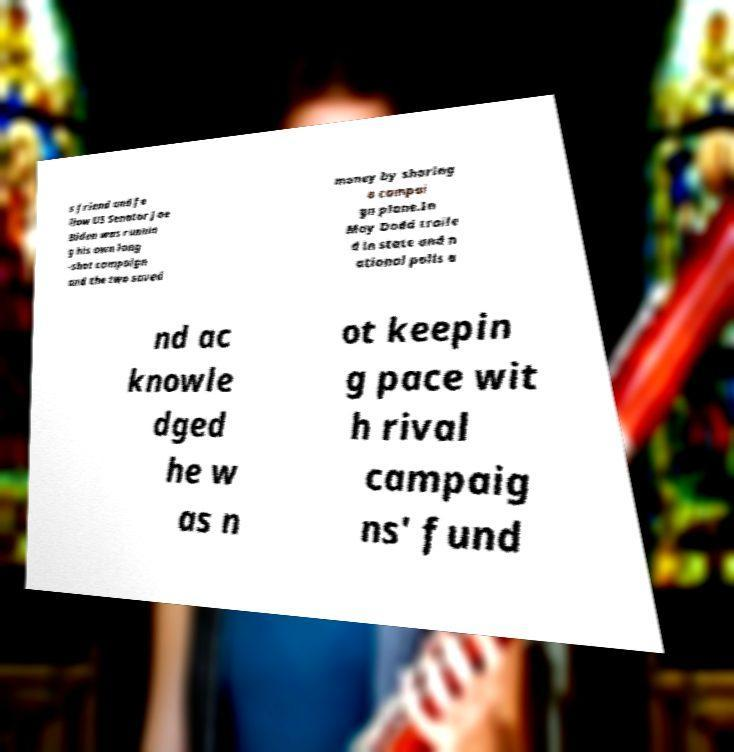Can you read and provide the text displayed in the image?This photo seems to have some interesting text. Can you extract and type it out for me? s friend and fe llow US Senator Joe Biden was runnin g his own long -shot campaign and the two saved money by sharing a campai gn plane.In May Dodd traile d in state and n ational polls a nd ac knowle dged he w as n ot keepin g pace wit h rival campaig ns' fund 